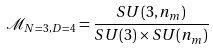<formula> <loc_0><loc_0><loc_500><loc_500>\mathcal { M } _ { N = 3 , D = 4 } = \frac { S U ( 3 , n _ { m } ) } { S U ( 3 ) \times S U ( n _ { m } ) }</formula> 